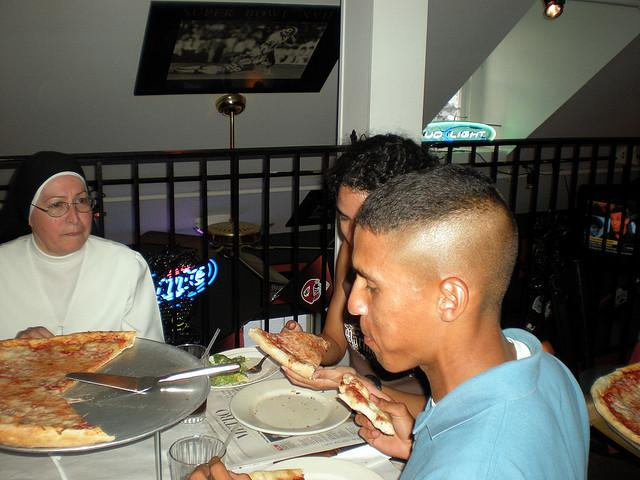What is this woman's profession? nun 